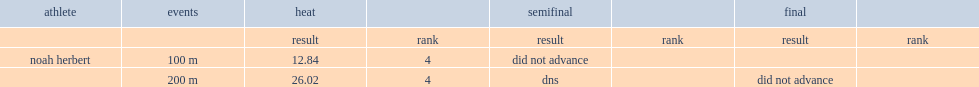Herbert participated in the 200 m and what was the place with 26.02? 4.0. 